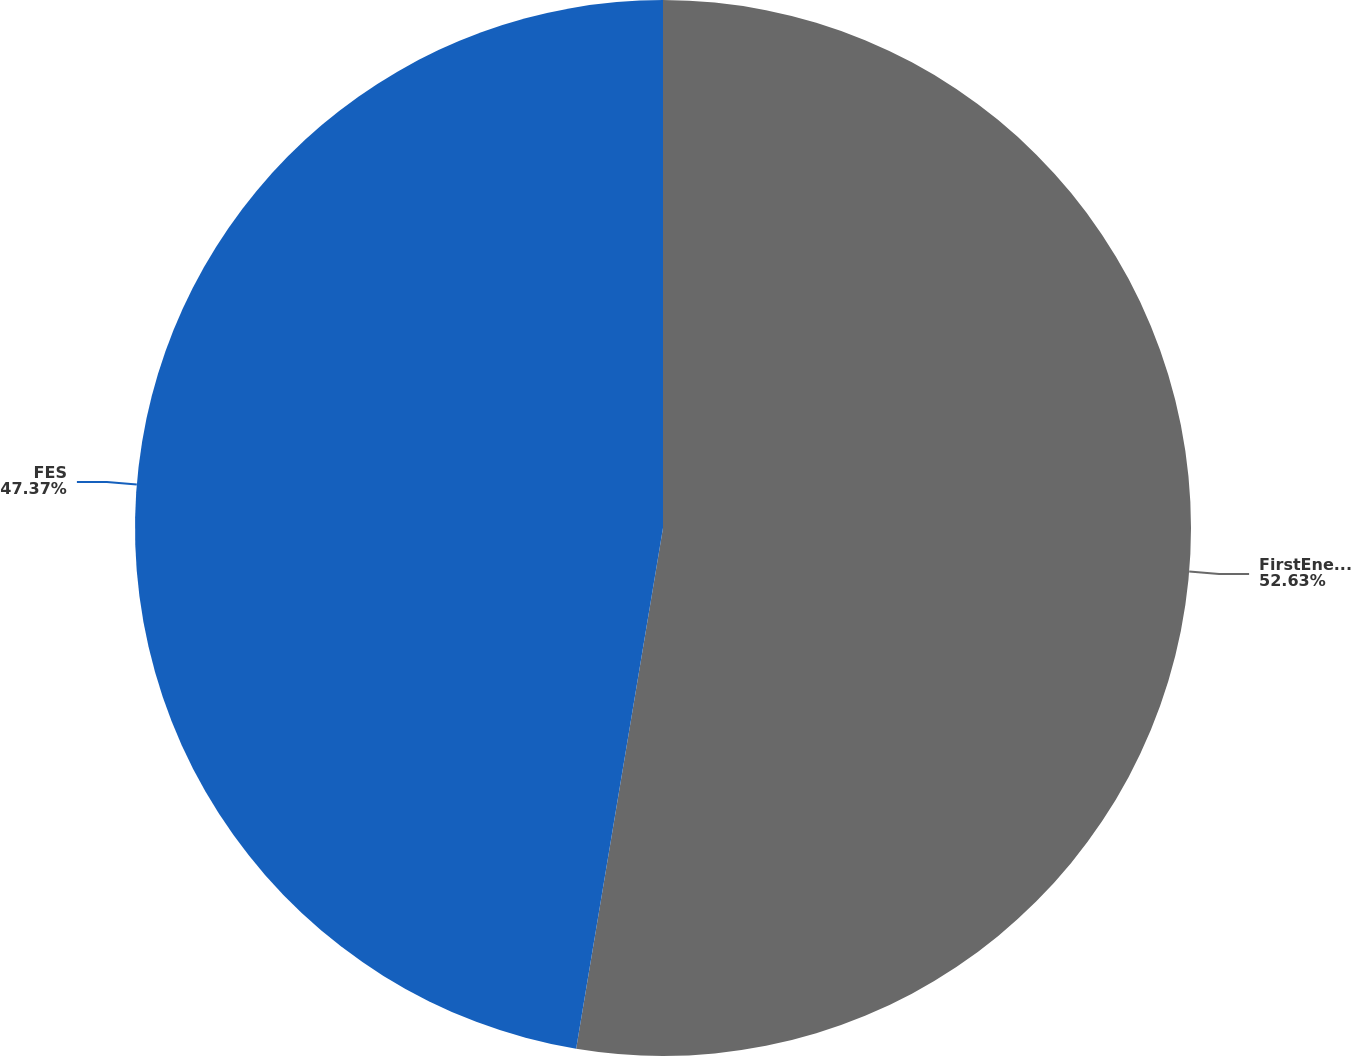Convert chart. <chart><loc_0><loc_0><loc_500><loc_500><pie_chart><fcel>FirstEnergy<fcel>FES<nl><fcel>52.63%<fcel>47.37%<nl></chart> 